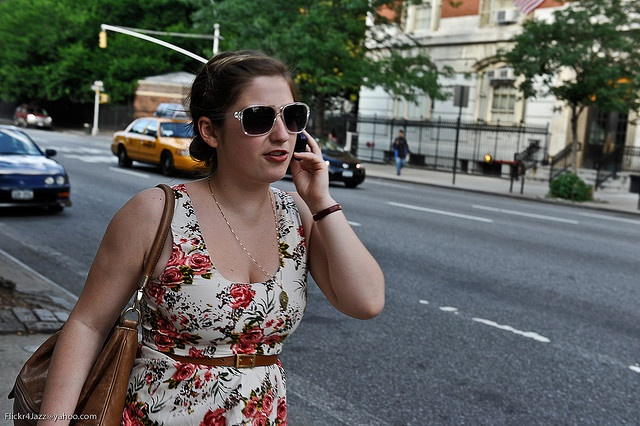Describe the objects in this image and their specific colors. I can see people in darkgreen, darkgray, black, maroon, and gray tones, handbag in darkgreen, black, maroon, and gray tones, car in darkgreen, black, navy, lavender, and darkgray tones, car in darkgreen, black, maroon, brown, and lightgray tones, and car in darkgreen, black, gray, darkgray, and navy tones in this image. 